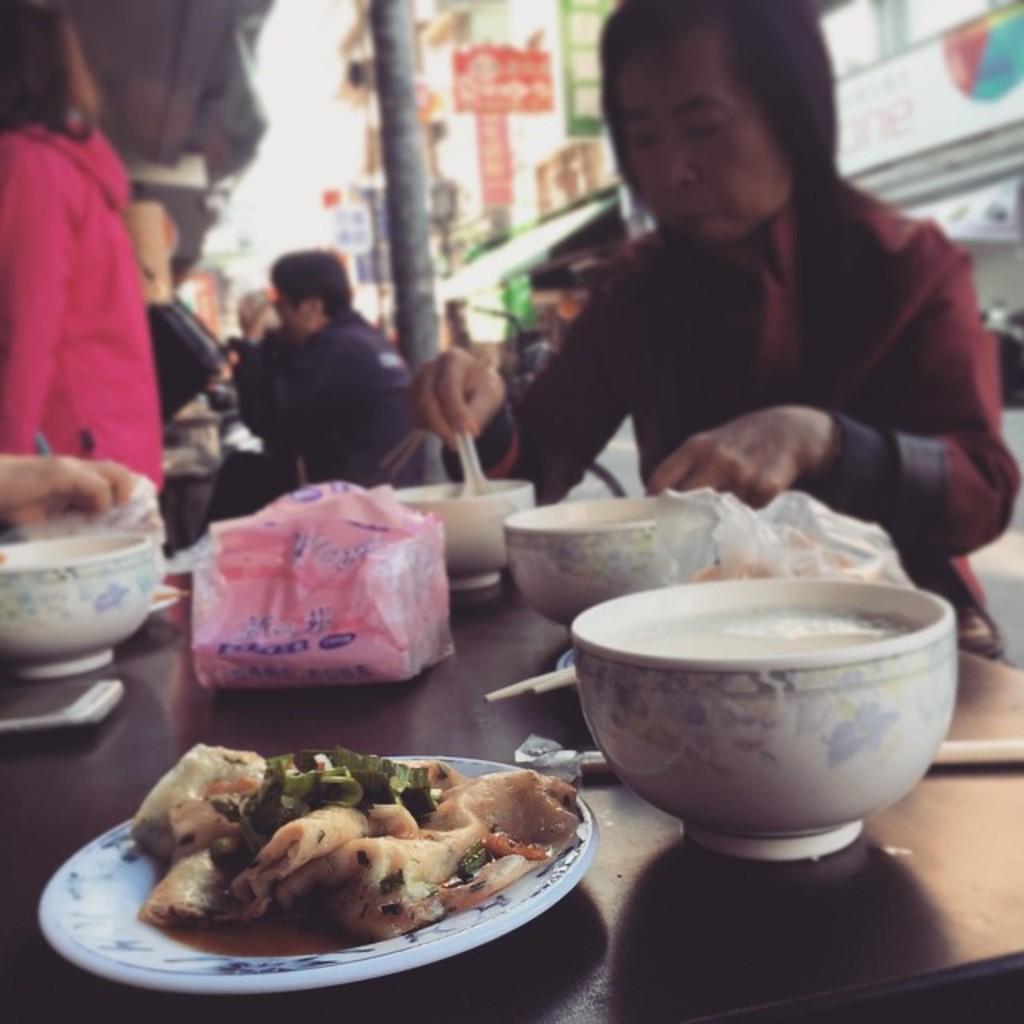Could you give a brief overview of what you see in this image? In this image there are some items served on the plate and some bowls on the table, there are a few people and few buildings. 